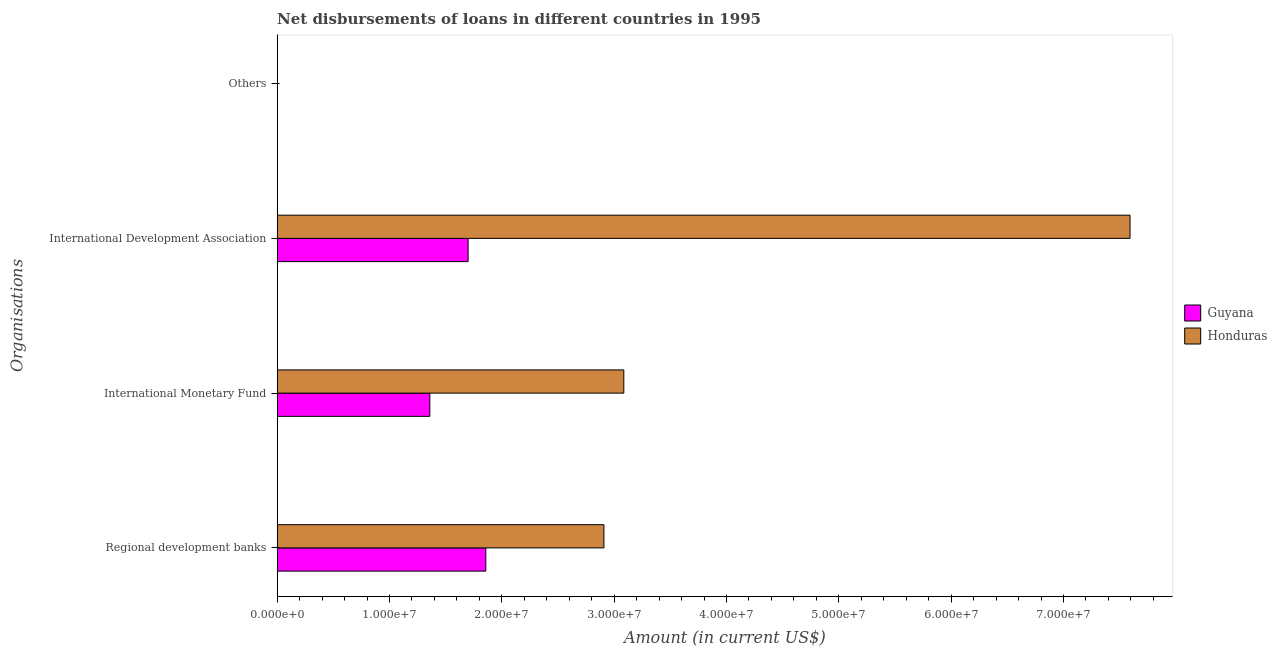Are the number of bars per tick equal to the number of legend labels?
Provide a short and direct response. No. Are the number of bars on each tick of the Y-axis equal?
Your answer should be compact. No. How many bars are there on the 3rd tick from the top?
Provide a short and direct response. 2. What is the label of the 1st group of bars from the top?
Provide a succinct answer. Others. What is the amount of loan disimbursed by international monetary fund in Guyana?
Provide a succinct answer. 1.36e+07. Across all countries, what is the maximum amount of loan disimbursed by international development association?
Keep it short and to the point. 7.59e+07. Across all countries, what is the minimum amount of loan disimbursed by international development association?
Ensure brevity in your answer.  1.70e+07. In which country was the amount of loan disimbursed by international monetary fund maximum?
Offer a very short reply. Honduras. What is the difference between the amount of loan disimbursed by international development association in Guyana and that in Honduras?
Keep it short and to the point. -5.89e+07. What is the difference between the amount of loan disimbursed by international monetary fund in Honduras and the amount of loan disimbursed by regional development banks in Guyana?
Provide a short and direct response. 1.23e+07. What is the average amount of loan disimbursed by international monetary fund per country?
Your answer should be very brief. 2.22e+07. What is the difference between the amount of loan disimbursed by international monetary fund and amount of loan disimbursed by regional development banks in Guyana?
Provide a short and direct response. -4.99e+06. What is the ratio of the amount of loan disimbursed by international monetary fund in Guyana to that in Honduras?
Offer a terse response. 0.44. Is the amount of loan disimbursed by international monetary fund in Honduras less than that in Guyana?
Provide a succinct answer. No. Is the difference between the amount of loan disimbursed by international development association in Honduras and Guyana greater than the difference between the amount of loan disimbursed by regional development banks in Honduras and Guyana?
Offer a terse response. Yes. What is the difference between the highest and the second highest amount of loan disimbursed by international monetary fund?
Give a very brief answer. 1.73e+07. What is the difference between the highest and the lowest amount of loan disimbursed by international development association?
Offer a terse response. 5.89e+07. In how many countries, is the amount of loan disimbursed by regional development banks greater than the average amount of loan disimbursed by regional development banks taken over all countries?
Your answer should be compact. 1. Is the sum of the amount of loan disimbursed by international development association in Honduras and Guyana greater than the maximum amount of loan disimbursed by other organisations across all countries?
Make the answer very short. Yes. Is it the case that in every country, the sum of the amount of loan disimbursed by international development association and amount of loan disimbursed by regional development banks is greater than the sum of amount of loan disimbursed by international monetary fund and amount of loan disimbursed by other organisations?
Make the answer very short. No. Is it the case that in every country, the sum of the amount of loan disimbursed by regional development banks and amount of loan disimbursed by international monetary fund is greater than the amount of loan disimbursed by international development association?
Ensure brevity in your answer.  No. Are all the bars in the graph horizontal?
Your answer should be compact. Yes. What is the difference between two consecutive major ticks on the X-axis?
Offer a very short reply. 1.00e+07. Are the values on the major ticks of X-axis written in scientific E-notation?
Your answer should be compact. Yes. Does the graph contain grids?
Offer a terse response. No. Where does the legend appear in the graph?
Ensure brevity in your answer.  Center right. How many legend labels are there?
Ensure brevity in your answer.  2. What is the title of the graph?
Provide a short and direct response. Net disbursements of loans in different countries in 1995. Does "Austria" appear as one of the legend labels in the graph?
Offer a very short reply. No. What is the label or title of the Y-axis?
Your answer should be very brief. Organisations. What is the Amount (in current US$) of Guyana in Regional development banks?
Ensure brevity in your answer.  1.86e+07. What is the Amount (in current US$) in Honduras in Regional development banks?
Ensure brevity in your answer.  2.91e+07. What is the Amount (in current US$) in Guyana in International Monetary Fund?
Your answer should be compact. 1.36e+07. What is the Amount (in current US$) in Honduras in International Monetary Fund?
Provide a succinct answer. 3.09e+07. What is the Amount (in current US$) of Guyana in International Development Association?
Ensure brevity in your answer.  1.70e+07. What is the Amount (in current US$) in Honduras in International Development Association?
Offer a terse response. 7.59e+07. What is the Amount (in current US$) in Honduras in Others?
Offer a terse response. 0. Across all Organisations, what is the maximum Amount (in current US$) in Guyana?
Make the answer very short. 1.86e+07. Across all Organisations, what is the maximum Amount (in current US$) in Honduras?
Make the answer very short. 7.59e+07. What is the total Amount (in current US$) in Guyana in the graph?
Ensure brevity in your answer.  4.92e+07. What is the total Amount (in current US$) in Honduras in the graph?
Your answer should be compact. 1.36e+08. What is the difference between the Amount (in current US$) of Guyana in Regional development banks and that in International Monetary Fund?
Offer a very short reply. 4.99e+06. What is the difference between the Amount (in current US$) of Honduras in Regional development banks and that in International Monetary Fund?
Your answer should be very brief. -1.77e+06. What is the difference between the Amount (in current US$) of Guyana in Regional development banks and that in International Development Association?
Your response must be concise. 1.58e+06. What is the difference between the Amount (in current US$) in Honduras in Regional development banks and that in International Development Association?
Provide a short and direct response. -4.68e+07. What is the difference between the Amount (in current US$) of Guyana in International Monetary Fund and that in International Development Association?
Your answer should be compact. -3.41e+06. What is the difference between the Amount (in current US$) of Honduras in International Monetary Fund and that in International Development Association?
Ensure brevity in your answer.  -4.51e+07. What is the difference between the Amount (in current US$) of Guyana in Regional development banks and the Amount (in current US$) of Honduras in International Monetary Fund?
Offer a terse response. -1.23e+07. What is the difference between the Amount (in current US$) of Guyana in Regional development banks and the Amount (in current US$) of Honduras in International Development Association?
Your answer should be compact. -5.73e+07. What is the difference between the Amount (in current US$) of Guyana in International Monetary Fund and the Amount (in current US$) of Honduras in International Development Association?
Your answer should be compact. -6.23e+07. What is the average Amount (in current US$) in Guyana per Organisations?
Ensure brevity in your answer.  1.23e+07. What is the average Amount (in current US$) of Honduras per Organisations?
Ensure brevity in your answer.  3.40e+07. What is the difference between the Amount (in current US$) of Guyana and Amount (in current US$) of Honduras in Regional development banks?
Offer a terse response. -1.05e+07. What is the difference between the Amount (in current US$) in Guyana and Amount (in current US$) in Honduras in International Monetary Fund?
Offer a very short reply. -1.73e+07. What is the difference between the Amount (in current US$) of Guyana and Amount (in current US$) of Honduras in International Development Association?
Your answer should be compact. -5.89e+07. What is the ratio of the Amount (in current US$) of Guyana in Regional development banks to that in International Monetary Fund?
Keep it short and to the point. 1.37. What is the ratio of the Amount (in current US$) of Honduras in Regional development banks to that in International Monetary Fund?
Offer a terse response. 0.94. What is the ratio of the Amount (in current US$) of Guyana in Regional development banks to that in International Development Association?
Provide a succinct answer. 1.09. What is the ratio of the Amount (in current US$) of Honduras in Regional development banks to that in International Development Association?
Ensure brevity in your answer.  0.38. What is the ratio of the Amount (in current US$) in Guyana in International Monetary Fund to that in International Development Association?
Give a very brief answer. 0.8. What is the ratio of the Amount (in current US$) in Honduras in International Monetary Fund to that in International Development Association?
Offer a terse response. 0.41. What is the difference between the highest and the second highest Amount (in current US$) of Guyana?
Your answer should be very brief. 1.58e+06. What is the difference between the highest and the second highest Amount (in current US$) of Honduras?
Give a very brief answer. 4.51e+07. What is the difference between the highest and the lowest Amount (in current US$) of Guyana?
Make the answer very short. 1.86e+07. What is the difference between the highest and the lowest Amount (in current US$) of Honduras?
Provide a short and direct response. 7.59e+07. 